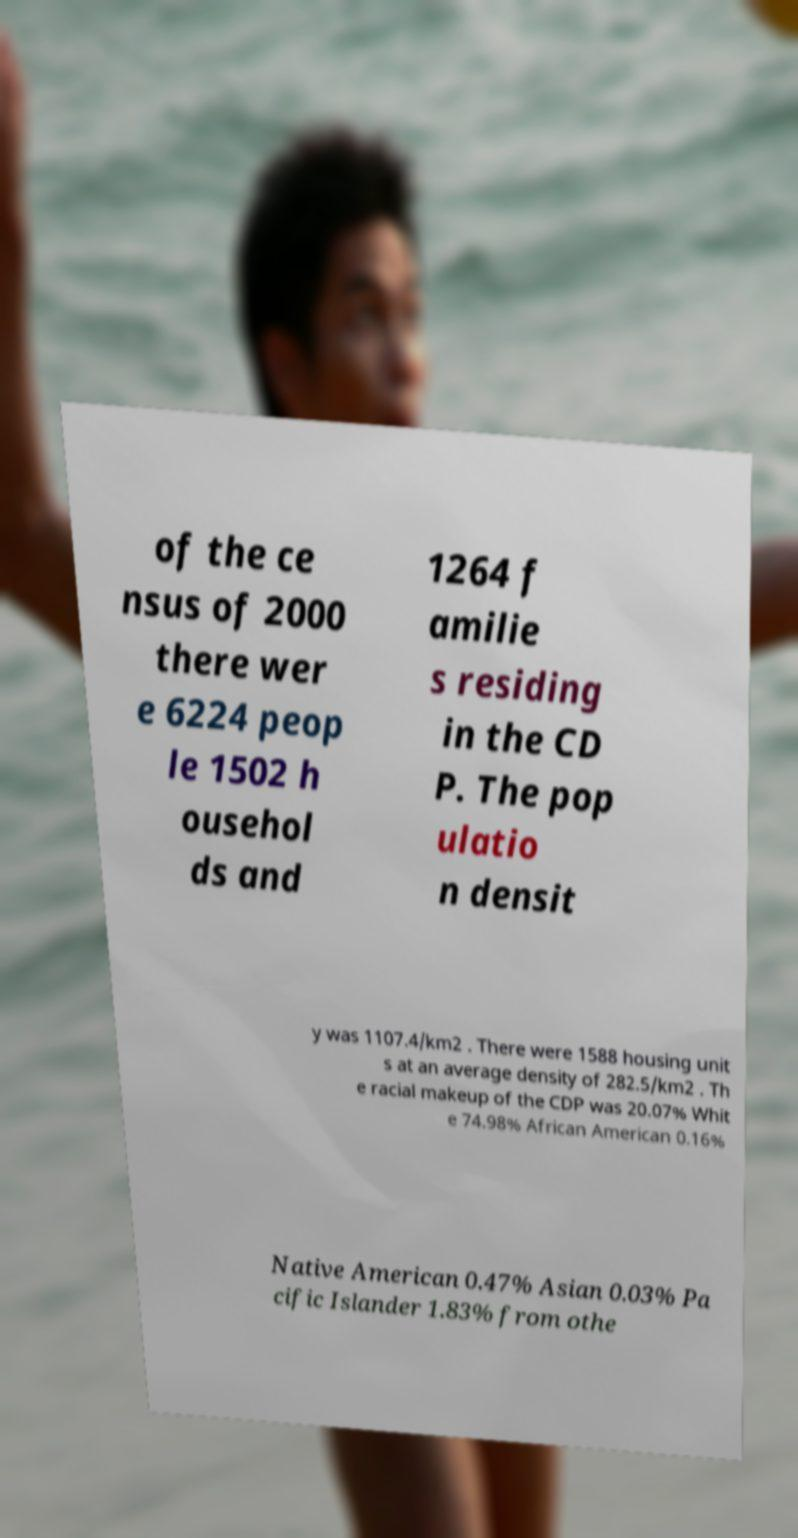There's text embedded in this image that I need extracted. Can you transcribe it verbatim? of the ce nsus of 2000 there wer e 6224 peop le 1502 h ousehol ds and 1264 f amilie s residing in the CD P. The pop ulatio n densit y was 1107.4/km2 . There were 1588 housing unit s at an average density of 282.5/km2 . Th e racial makeup of the CDP was 20.07% Whit e 74.98% African American 0.16% Native American 0.47% Asian 0.03% Pa cific Islander 1.83% from othe 